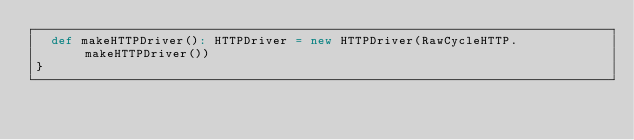<code> <loc_0><loc_0><loc_500><loc_500><_Scala_>  def makeHTTPDriver(): HTTPDriver = new HTTPDriver(RawCycleHTTP.makeHTTPDriver())
}
</code> 